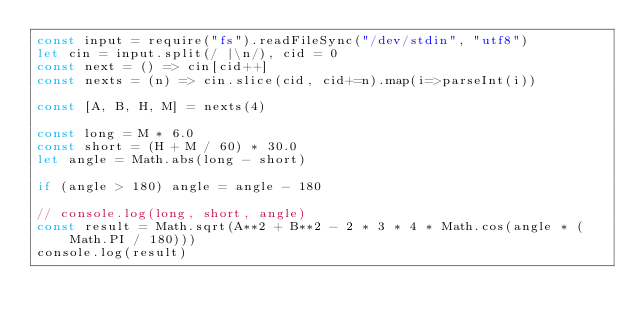Convert code to text. <code><loc_0><loc_0><loc_500><loc_500><_JavaScript_>const input = require("fs").readFileSync("/dev/stdin", "utf8")
let cin = input.split(/ |\n/), cid = 0
const next = () => cin[cid++]
const nexts = (n) => cin.slice(cid, cid+=n).map(i=>parseInt(i))

const [A, B, H, M] = nexts(4)

const long = M * 6.0
const short = (H + M / 60) * 30.0
let angle = Math.abs(long - short)

if (angle > 180) angle = angle - 180

// console.log(long, short, angle)
const result = Math.sqrt(A**2 + B**2 - 2 * 3 * 4 * Math.cos(angle * (Math.PI / 180)))
console.log(result)
</code> 